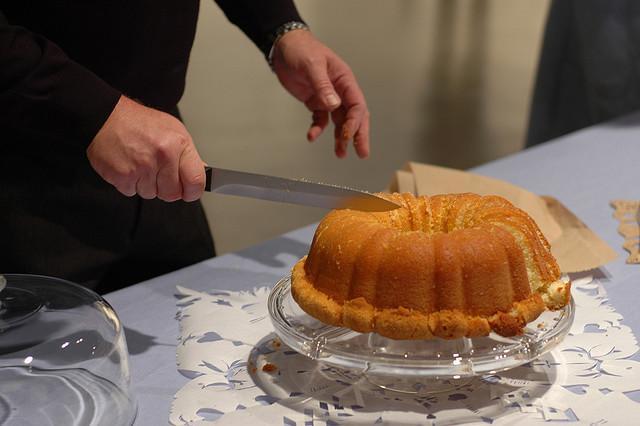What type of cake is this?
Choose the correct response and explain in the format: 'Answer: answer
Rationale: rationale.'
Options: Garash cake, circle cake, cupcake, bondt cake. Answer: bondt cake.
Rationale: It has a classic shape of that type of pan 